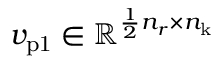<formula> <loc_0><loc_0><loc_500><loc_500>v _ { p 1 } \in \mathbb { R } ^ { \frac { 1 } { 2 } n _ { r } \times n _ { k } }</formula> 